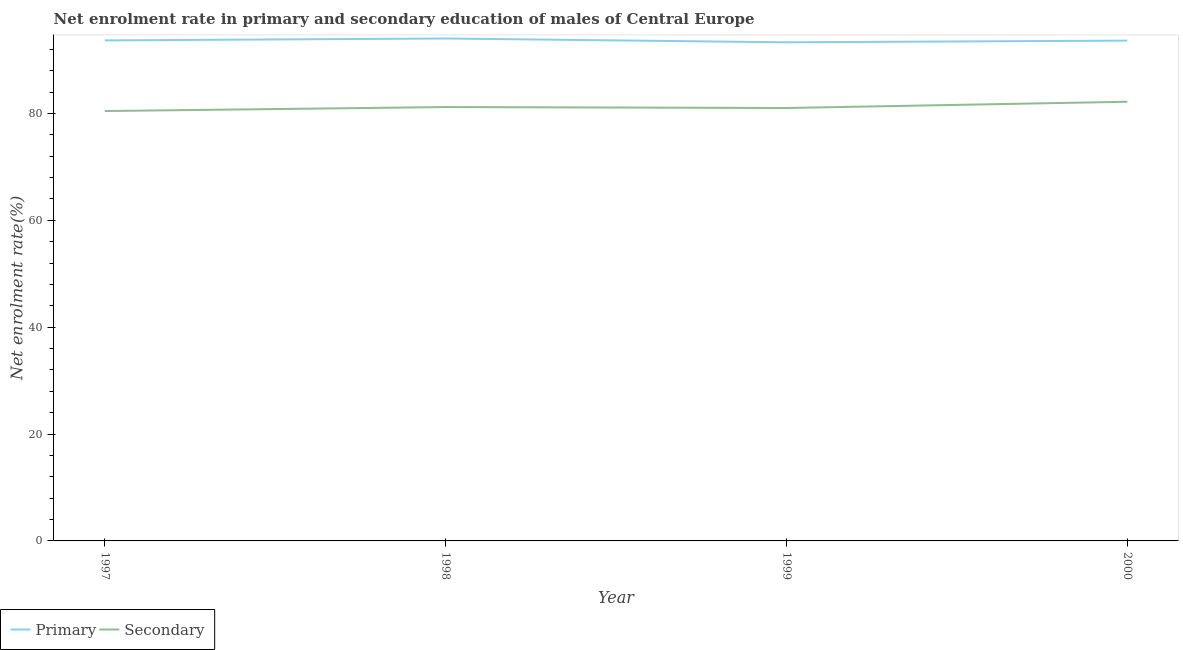How many different coloured lines are there?
Ensure brevity in your answer.  2. Is the number of lines equal to the number of legend labels?
Offer a very short reply. Yes. What is the enrollment rate in primary education in 1998?
Make the answer very short. 94.02. Across all years, what is the maximum enrollment rate in primary education?
Provide a succinct answer. 94.02. Across all years, what is the minimum enrollment rate in primary education?
Offer a terse response. 93.31. In which year was the enrollment rate in secondary education maximum?
Offer a very short reply. 2000. In which year was the enrollment rate in primary education minimum?
Ensure brevity in your answer.  1999. What is the total enrollment rate in primary education in the graph?
Keep it short and to the point. 374.63. What is the difference between the enrollment rate in secondary education in 1997 and that in 1998?
Give a very brief answer. -0.75. What is the difference between the enrollment rate in secondary education in 1999 and the enrollment rate in primary education in 1997?
Provide a succinct answer. -12.65. What is the average enrollment rate in secondary education per year?
Your response must be concise. 81.21. In the year 2000, what is the difference between the enrollment rate in secondary education and enrollment rate in primary education?
Your response must be concise. -11.44. What is the ratio of the enrollment rate in secondary education in 1998 to that in 2000?
Offer a very short reply. 0.99. Is the enrollment rate in primary education in 1997 less than that in 1999?
Provide a short and direct response. No. Is the difference between the enrollment rate in secondary education in 1997 and 1998 greater than the difference between the enrollment rate in primary education in 1997 and 1998?
Provide a succinct answer. No. What is the difference between the highest and the second highest enrollment rate in primary education?
Offer a very short reply. 0.35. What is the difference between the highest and the lowest enrollment rate in secondary education?
Provide a succinct answer. 1.74. In how many years, is the enrollment rate in primary education greater than the average enrollment rate in primary education taken over all years?
Offer a very short reply. 2. Is the sum of the enrollment rate in secondary education in 1997 and 1998 greater than the maximum enrollment rate in primary education across all years?
Provide a short and direct response. Yes. Does the enrollment rate in secondary education monotonically increase over the years?
Offer a very short reply. No. Is the enrollment rate in primary education strictly greater than the enrollment rate in secondary education over the years?
Keep it short and to the point. Yes. Is the enrollment rate in primary education strictly less than the enrollment rate in secondary education over the years?
Your response must be concise. No. How many years are there in the graph?
Offer a terse response. 4. What is the difference between two consecutive major ticks on the Y-axis?
Provide a short and direct response. 20. Does the graph contain grids?
Provide a short and direct response. No. Where does the legend appear in the graph?
Keep it short and to the point. Bottom left. What is the title of the graph?
Offer a terse response. Net enrolment rate in primary and secondary education of males of Central Europe. Does "Public funds" appear as one of the legend labels in the graph?
Ensure brevity in your answer.  No. What is the label or title of the X-axis?
Your answer should be very brief. Year. What is the label or title of the Y-axis?
Give a very brief answer. Net enrolment rate(%). What is the Net enrolment rate(%) of Primary in 1997?
Give a very brief answer. 93.67. What is the Net enrolment rate(%) of Secondary in 1997?
Give a very brief answer. 80.45. What is the Net enrolment rate(%) of Primary in 1998?
Provide a succinct answer. 94.02. What is the Net enrolment rate(%) of Secondary in 1998?
Make the answer very short. 81.19. What is the Net enrolment rate(%) in Primary in 1999?
Provide a succinct answer. 93.31. What is the Net enrolment rate(%) of Secondary in 1999?
Give a very brief answer. 81.02. What is the Net enrolment rate(%) of Primary in 2000?
Offer a terse response. 93.62. What is the Net enrolment rate(%) of Secondary in 2000?
Make the answer very short. 82.19. Across all years, what is the maximum Net enrolment rate(%) of Primary?
Your answer should be very brief. 94.02. Across all years, what is the maximum Net enrolment rate(%) of Secondary?
Offer a terse response. 82.19. Across all years, what is the minimum Net enrolment rate(%) of Primary?
Provide a short and direct response. 93.31. Across all years, what is the minimum Net enrolment rate(%) of Secondary?
Your answer should be compact. 80.45. What is the total Net enrolment rate(%) in Primary in the graph?
Your response must be concise. 374.63. What is the total Net enrolment rate(%) in Secondary in the graph?
Offer a very short reply. 324.84. What is the difference between the Net enrolment rate(%) in Primary in 1997 and that in 1998?
Keep it short and to the point. -0.35. What is the difference between the Net enrolment rate(%) of Secondary in 1997 and that in 1998?
Offer a terse response. -0.75. What is the difference between the Net enrolment rate(%) in Primary in 1997 and that in 1999?
Keep it short and to the point. 0.36. What is the difference between the Net enrolment rate(%) of Secondary in 1997 and that in 1999?
Make the answer very short. -0.57. What is the difference between the Net enrolment rate(%) in Primary in 1997 and that in 2000?
Your answer should be compact. 0.04. What is the difference between the Net enrolment rate(%) of Secondary in 1997 and that in 2000?
Offer a very short reply. -1.74. What is the difference between the Net enrolment rate(%) of Primary in 1998 and that in 1999?
Ensure brevity in your answer.  0.71. What is the difference between the Net enrolment rate(%) of Secondary in 1998 and that in 1999?
Offer a terse response. 0.18. What is the difference between the Net enrolment rate(%) of Primary in 1998 and that in 2000?
Offer a very short reply. 0.4. What is the difference between the Net enrolment rate(%) in Secondary in 1998 and that in 2000?
Give a very brief answer. -0.99. What is the difference between the Net enrolment rate(%) in Primary in 1999 and that in 2000?
Offer a terse response. -0.31. What is the difference between the Net enrolment rate(%) of Secondary in 1999 and that in 2000?
Your answer should be compact. -1.17. What is the difference between the Net enrolment rate(%) of Primary in 1997 and the Net enrolment rate(%) of Secondary in 1998?
Offer a very short reply. 12.47. What is the difference between the Net enrolment rate(%) in Primary in 1997 and the Net enrolment rate(%) in Secondary in 1999?
Provide a succinct answer. 12.65. What is the difference between the Net enrolment rate(%) of Primary in 1997 and the Net enrolment rate(%) of Secondary in 2000?
Ensure brevity in your answer.  11.48. What is the difference between the Net enrolment rate(%) of Primary in 1998 and the Net enrolment rate(%) of Secondary in 1999?
Your answer should be very brief. 13. What is the difference between the Net enrolment rate(%) of Primary in 1998 and the Net enrolment rate(%) of Secondary in 2000?
Provide a succinct answer. 11.84. What is the difference between the Net enrolment rate(%) in Primary in 1999 and the Net enrolment rate(%) in Secondary in 2000?
Give a very brief answer. 11.13. What is the average Net enrolment rate(%) of Primary per year?
Give a very brief answer. 93.66. What is the average Net enrolment rate(%) of Secondary per year?
Provide a succinct answer. 81.21. In the year 1997, what is the difference between the Net enrolment rate(%) in Primary and Net enrolment rate(%) in Secondary?
Keep it short and to the point. 13.22. In the year 1998, what is the difference between the Net enrolment rate(%) in Primary and Net enrolment rate(%) in Secondary?
Provide a short and direct response. 12.83. In the year 1999, what is the difference between the Net enrolment rate(%) of Primary and Net enrolment rate(%) of Secondary?
Give a very brief answer. 12.3. In the year 2000, what is the difference between the Net enrolment rate(%) of Primary and Net enrolment rate(%) of Secondary?
Your answer should be very brief. 11.44. What is the ratio of the Net enrolment rate(%) in Primary in 1997 to that in 1998?
Your answer should be very brief. 1. What is the ratio of the Net enrolment rate(%) in Primary in 1997 to that in 1999?
Make the answer very short. 1. What is the ratio of the Net enrolment rate(%) of Secondary in 1997 to that in 1999?
Your answer should be compact. 0.99. What is the ratio of the Net enrolment rate(%) of Secondary in 1997 to that in 2000?
Keep it short and to the point. 0.98. What is the ratio of the Net enrolment rate(%) of Primary in 1998 to that in 1999?
Keep it short and to the point. 1.01. What is the ratio of the Net enrolment rate(%) of Secondary in 1998 to that in 1999?
Your answer should be compact. 1. What is the ratio of the Net enrolment rate(%) of Secondary in 1998 to that in 2000?
Your response must be concise. 0.99. What is the ratio of the Net enrolment rate(%) of Secondary in 1999 to that in 2000?
Provide a short and direct response. 0.99. What is the difference between the highest and the second highest Net enrolment rate(%) of Primary?
Give a very brief answer. 0.35. What is the difference between the highest and the second highest Net enrolment rate(%) in Secondary?
Make the answer very short. 0.99. What is the difference between the highest and the lowest Net enrolment rate(%) in Primary?
Offer a very short reply. 0.71. What is the difference between the highest and the lowest Net enrolment rate(%) in Secondary?
Your answer should be compact. 1.74. 